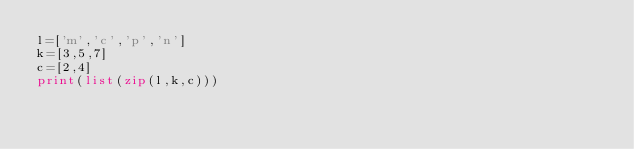<code> <loc_0><loc_0><loc_500><loc_500><_Python_>l=['m','c','p','n']
k=[3,5,7]
c=[2,4]
print(list(zip(l,k,c)))</code> 